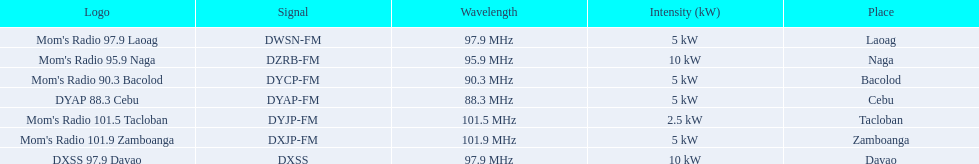What is the last location on this chart? Davao. 